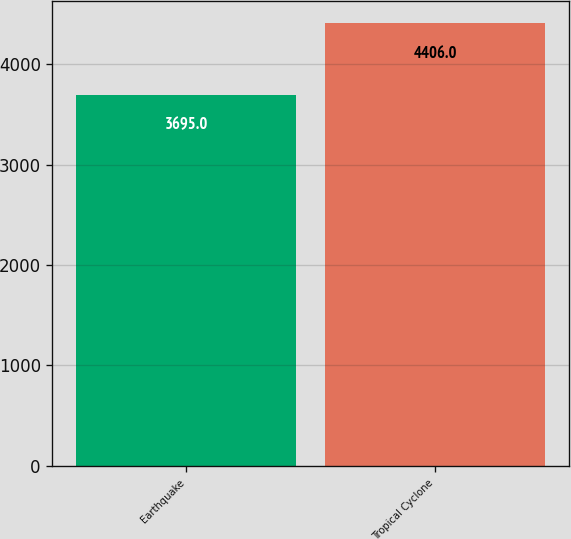<chart> <loc_0><loc_0><loc_500><loc_500><bar_chart><fcel>Earthquake<fcel>Tropical Cyclone<nl><fcel>3695<fcel>4406<nl></chart> 